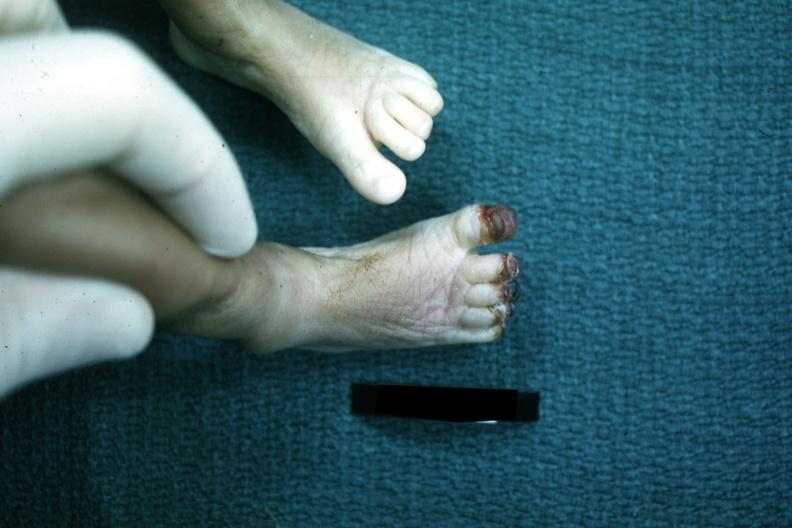how does this image show foot of infant?
Answer the question using a single word or phrase. With gangrenous tips all toes case sepsis with dic 